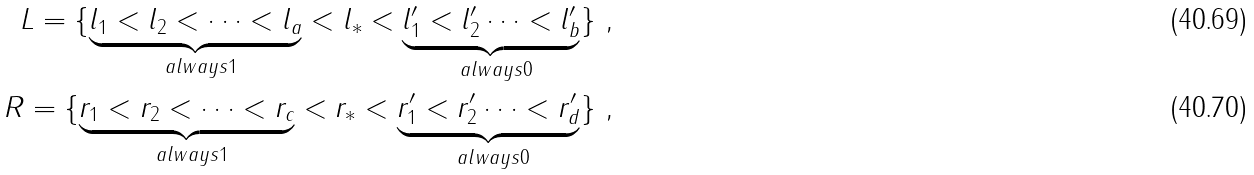Convert formula to latex. <formula><loc_0><loc_0><loc_500><loc_500>L = \{ \underbrace { l _ { 1 } < l _ { 2 } < \cdots < l _ { a } } _ { \ a l w a y s { 1 } } < l _ { * } < \underbrace { l _ { 1 } ^ { \prime } < l _ { 2 } ^ { \prime } \cdots < l _ { b } ^ { \prime } } _ { \ a l w a y s { 0 } } \} \ , \\ R = \{ \underbrace { r _ { 1 } < r _ { 2 } < \cdots < r _ { c } } _ { \ a l w a y s { 1 } } < r _ { * } < \underbrace { r _ { 1 } ^ { \prime } < r _ { 2 } ^ { \prime } \cdots < r _ { d } ^ { \prime } } _ { \ a l w a y s { 0 } } \} \ ,</formula> 